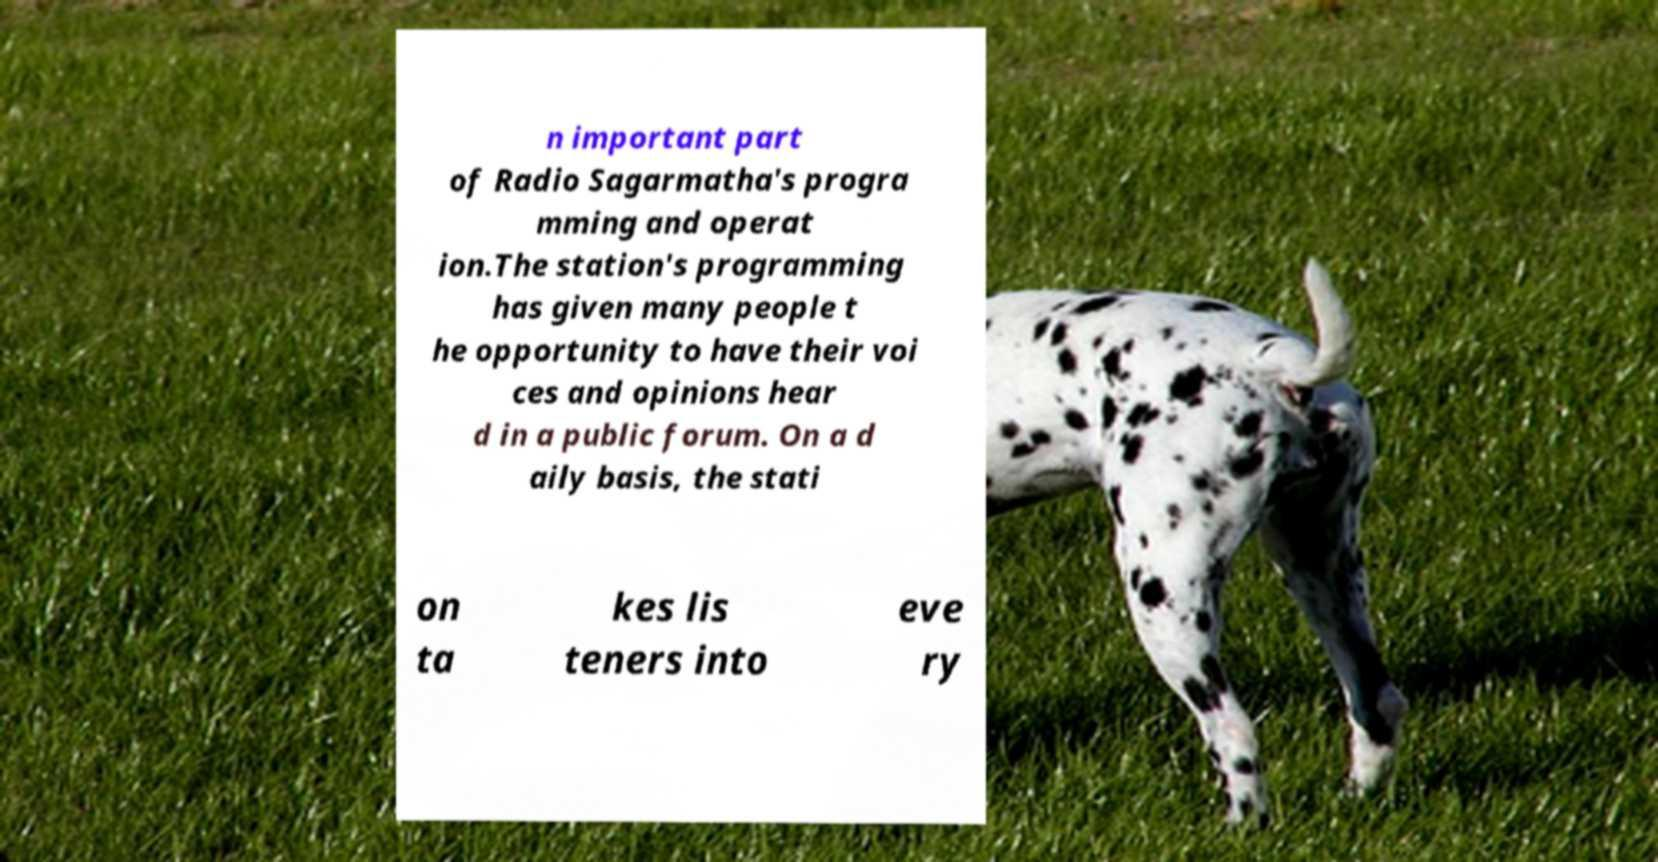Please identify and transcribe the text found in this image. n important part of Radio Sagarmatha's progra mming and operat ion.The station's programming has given many people t he opportunity to have their voi ces and opinions hear d in a public forum. On a d aily basis, the stati on ta kes lis teners into eve ry 